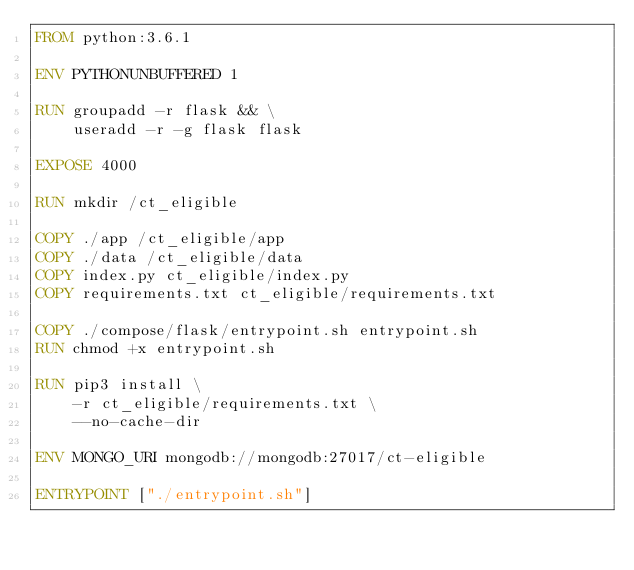<code> <loc_0><loc_0><loc_500><loc_500><_Dockerfile_>FROM python:3.6.1

ENV PYTHONUNBUFFERED 1

RUN groupadd -r flask && \
    useradd -r -g flask flask

EXPOSE 4000

RUN mkdir /ct_eligible

COPY ./app /ct_eligible/app
COPY ./data /ct_eligible/data
COPY index.py ct_eligible/index.py
COPY requirements.txt ct_eligible/requirements.txt

COPY ./compose/flask/entrypoint.sh entrypoint.sh
RUN chmod +x entrypoint.sh

RUN pip3 install \
    -r ct_eligible/requirements.txt \
    --no-cache-dir

ENV MONGO_URI mongodb://mongodb:27017/ct-eligible

ENTRYPOINT ["./entrypoint.sh"]
</code> 